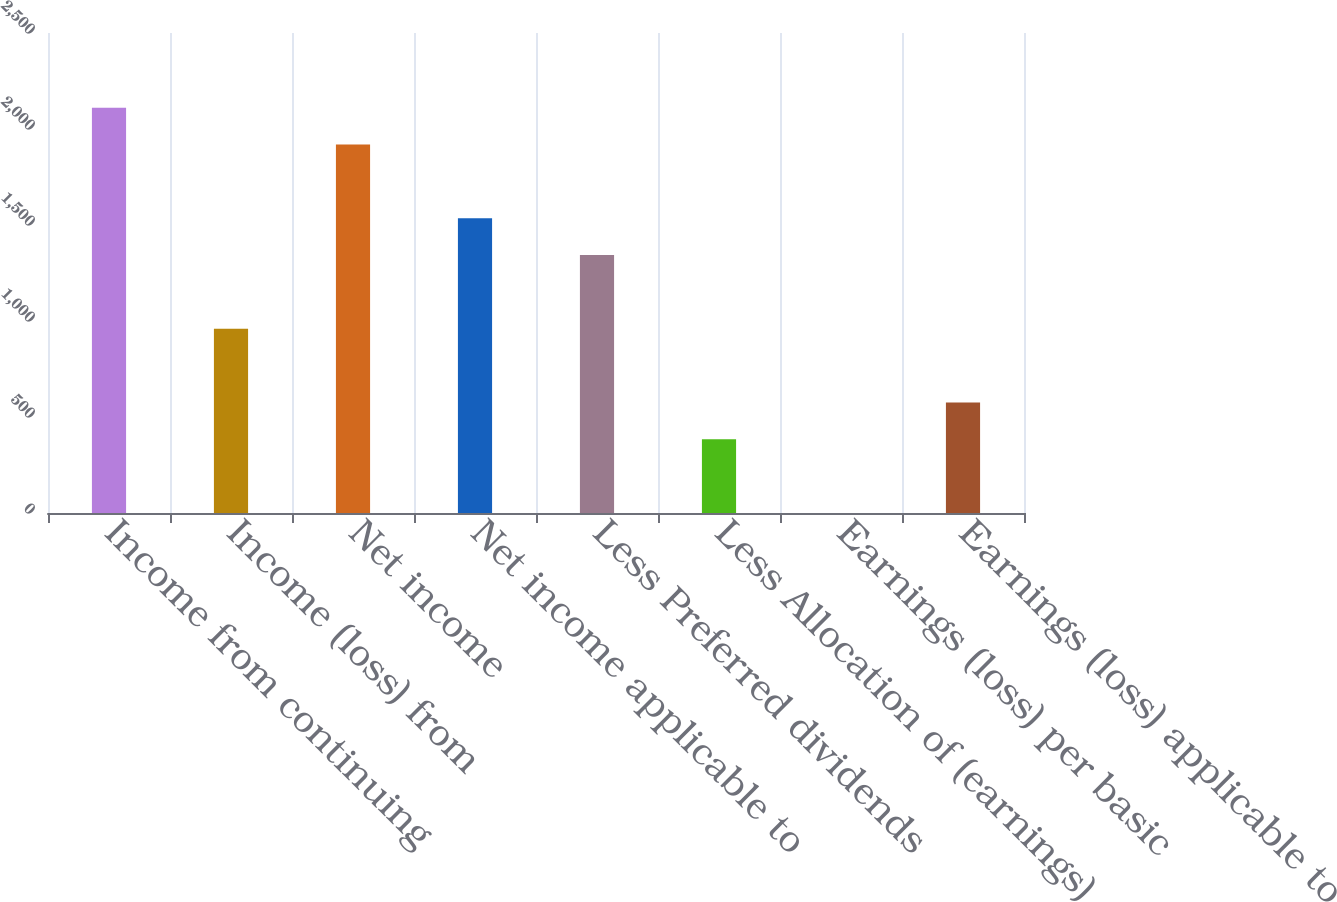<chart> <loc_0><loc_0><loc_500><loc_500><bar_chart><fcel>Income from continuing<fcel>Income (loss) from<fcel>Net income<fcel>Net income applicable to<fcel>Less Preferred dividends<fcel>Less Allocation of (earnings)<fcel>Earnings (loss) per basic<fcel>Earnings (loss) applicable to<nl><fcel>2110.92<fcel>959.52<fcel>1919.02<fcel>1535.22<fcel>1343.32<fcel>383.82<fcel>0.02<fcel>575.72<nl></chart> 